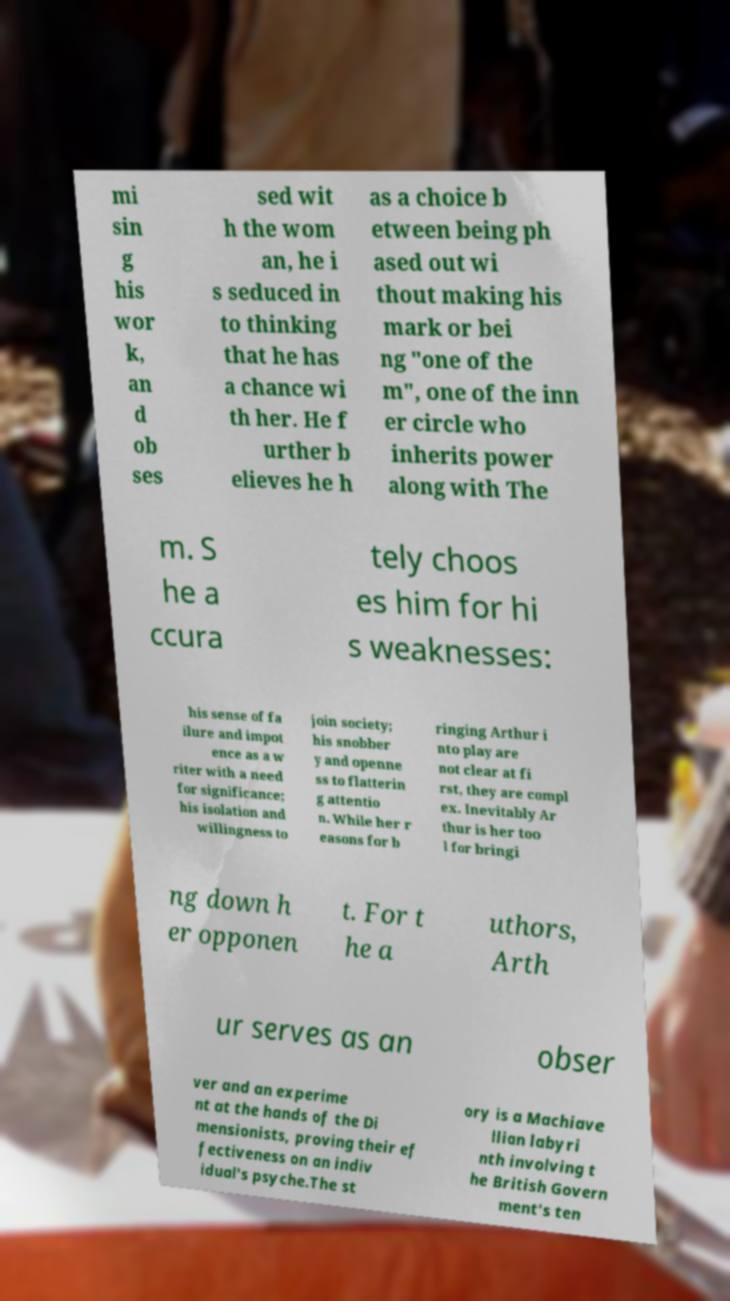Please identify and transcribe the text found in this image. mi sin g his wor k, an d ob ses sed wit h the wom an, he i s seduced in to thinking that he has a chance wi th her. He f urther b elieves he h as a choice b etween being ph ased out wi thout making his mark or bei ng "one of the m", one of the inn er circle who inherits power along with The m. S he a ccura tely choos es him for hi s weaknesses: his sense of fa ilure and impot ence as a w riter with a need for significance; his isolation and willingness to join society; his snobber y and openne ss to flatterin g attentio n. While her r easons for b ringing Arthur i nto play are not clear at fi rst, they are compl ex. Inevitably Ar thur is her too l for bringi ng down h er opponen t. For t he a uthors, Arth ur serves as an obser ver and an experime nt at the hands of the Di mensionists, proving their ef fectiveness on an indiv idual's psyche.The st ory is a Machiave llian labyri nth involving t he British Govern ment's ten 